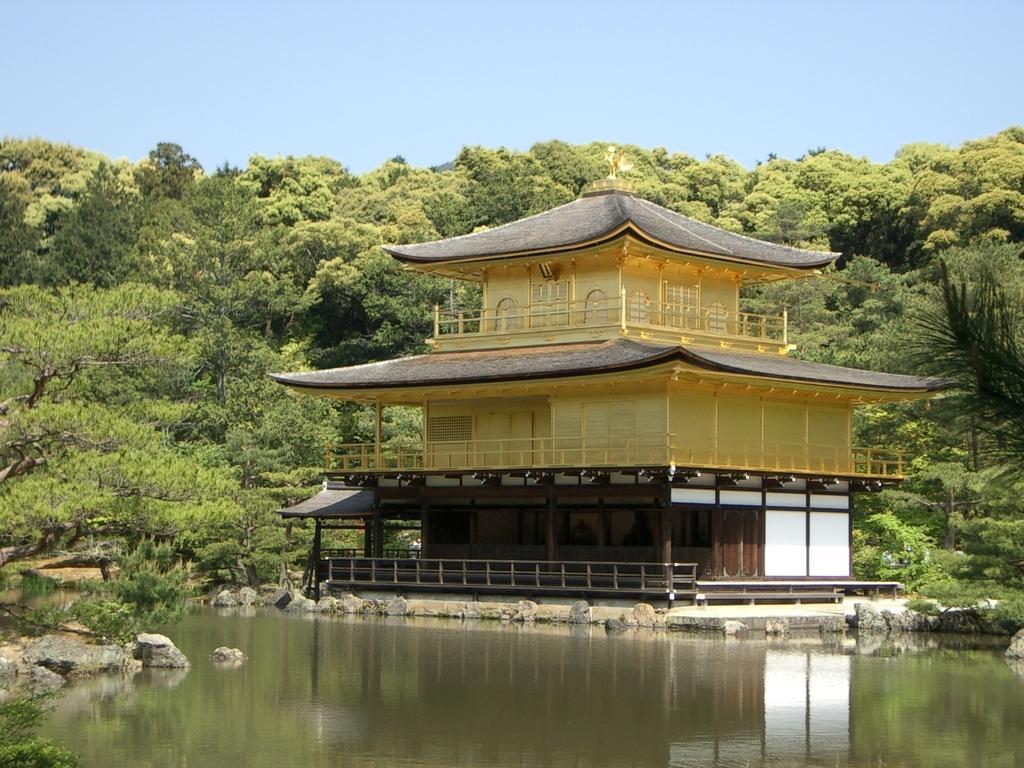Describe this image in one or two sentences. At the bottom of the image we can see water and stones. In the middle of the image we can see a building. Behind the building we can see some trees. At the top of the image we can see the sky. 